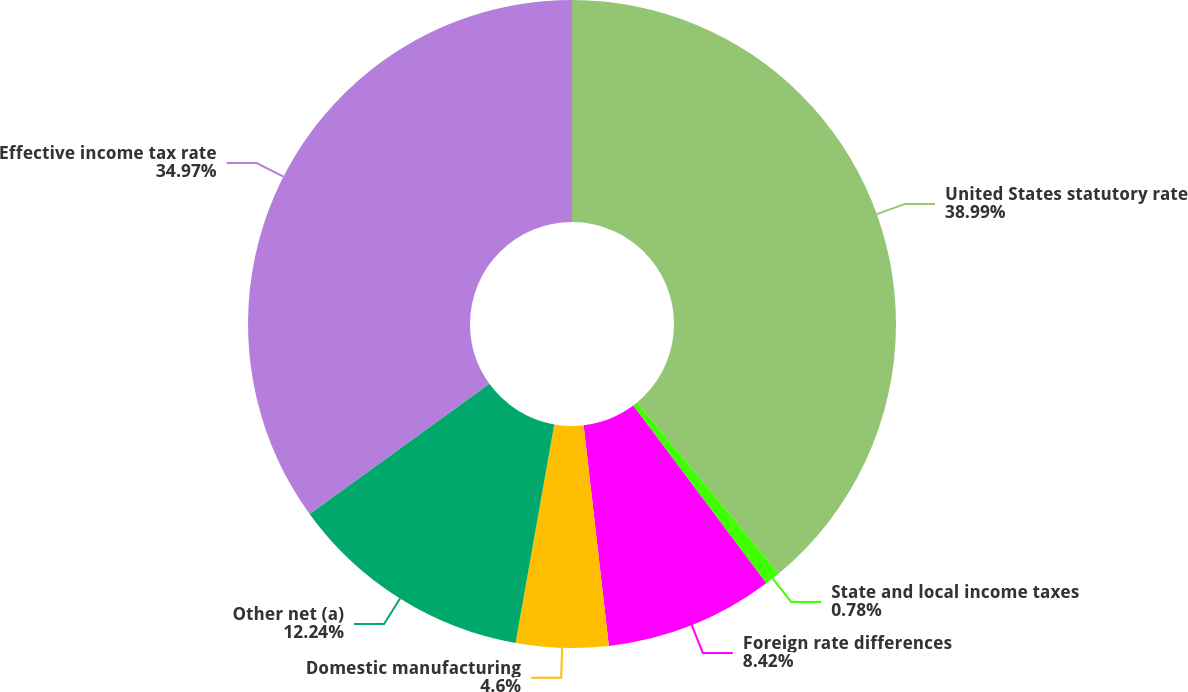Convert chart to OTSL. <chart><loc_0><loc_0><loc_500><loc_500><pie_chart><fcel>United States statutory rate<fcel>State and local income taxes<fcel>Foreign rate differences<fcel>Domestic manufacturing<fcel>Other net (a)<fcel>Effective income tax rate<nl><fcel>38.98%<fcel>0.78%<fcel>8.42%<fcel>4.6%<fcel>12.24%<fcel>34.97%<nl></chart> 